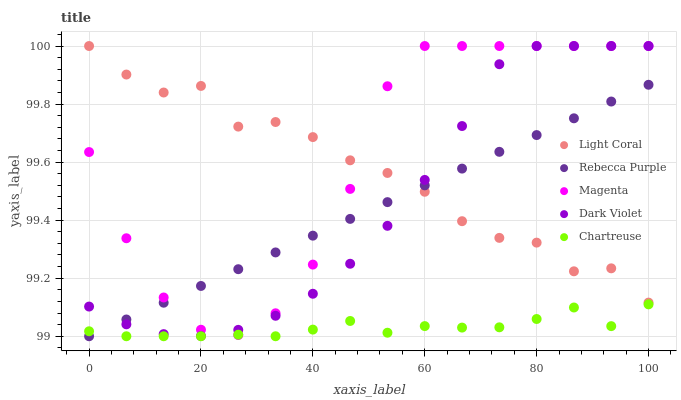Does Chartreuse have the minimum area under the curve?
Answer yes or no. Yes. Does Magenta have the maximum area under the curve?
Answer yes or no. Yes. Does Magenta have the minimum area under the curve?
Answer yes or no. No. Does Chartreuse have the maximum area under the curve?
Answer yes or no. No. Is Rebecca Purple the smoothest?
Answer yes or no. Yes. Is Light Coral the roughest?
Answer yes or no. Yes. Is Chartreuse the smoothest?
Answer yes or no. No. Is Chartreuse the roughest?
Answer yes or no. No. Does Chartreuse have the lowest value?
Answer yes or no. Yes. Does Magenta have the lowest value?
Answer yes or no. No. Does Dark Violet have the highest value?
Answer yes or no. Yes. Does Chartreuse have the highest value?
Answer yes or no. No. Is Chartreuse less than Light Coral?
Answer yes or no. Yes. Is Dark Violet greater than Chartreuse?
Answer yes or no. Yes. Does Chartreuse intersect Rebecca Purple?
Answer yes or no. Yes. Is Chartreuse less than Rebecca Purple?
Answer yes or no. No. Is Chartreuse greater than Rebecca Purple?
Answer yes or no. No. Does Chartreuse intersect Light Coral?
Answer yes or no. No. 